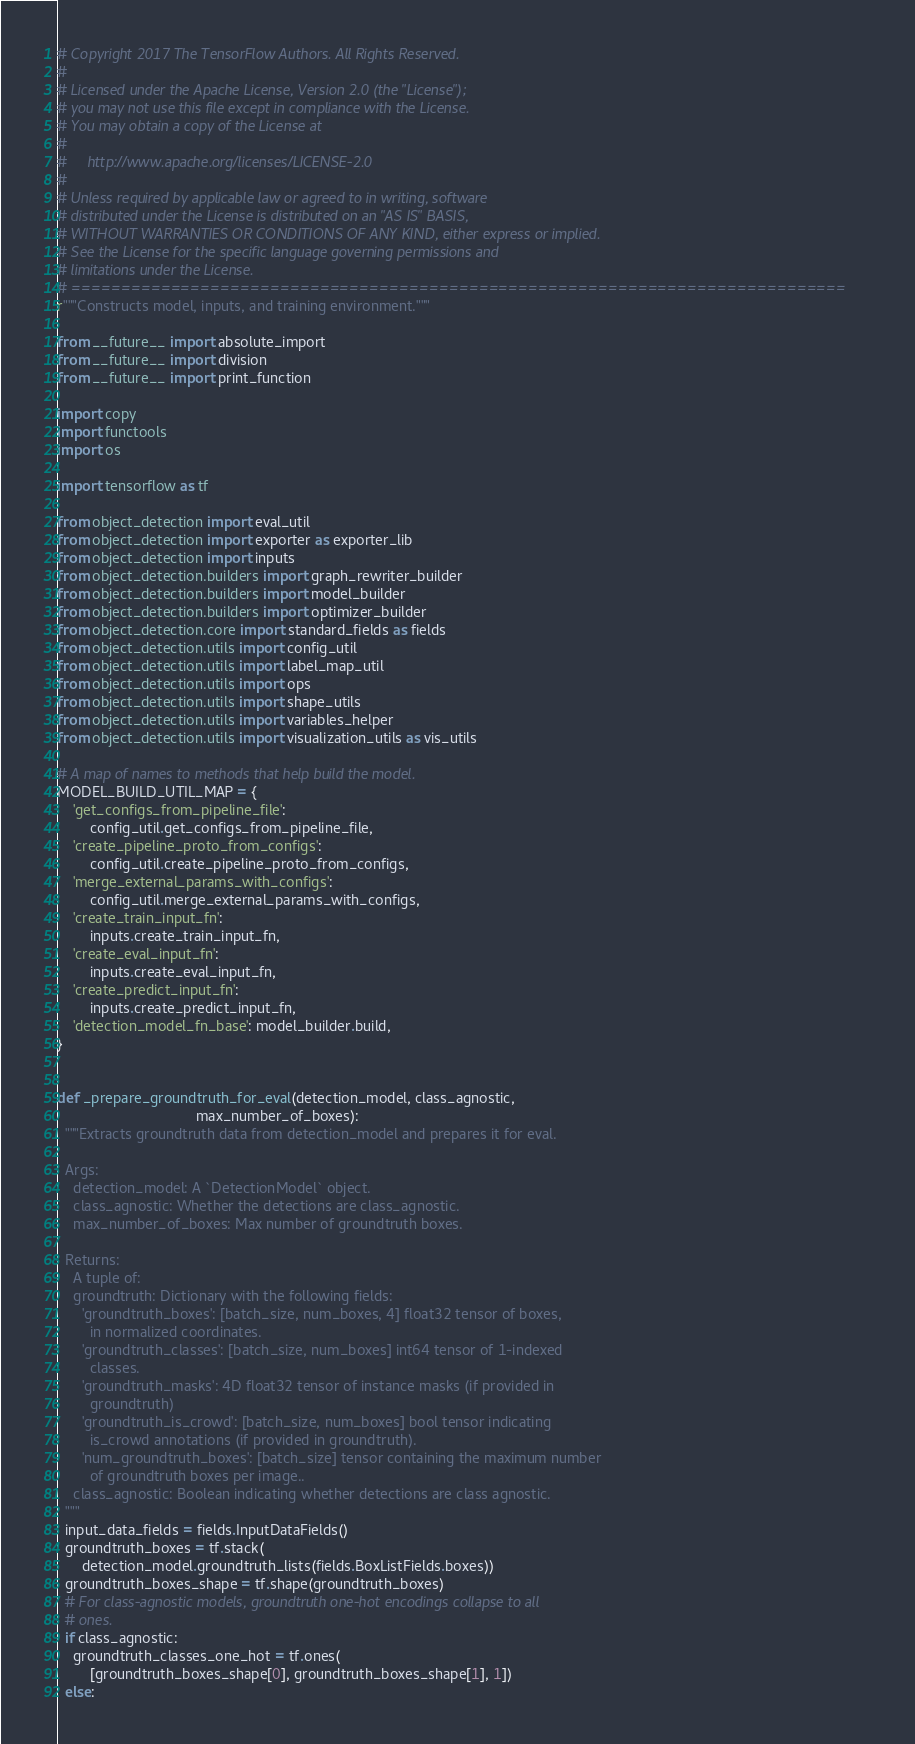Convert code to text. <code><loc_0><loc_0><loc_500><loc_500><_Python_># Copyright 2017 The TensorFlow Authors. All Rights Reserved.
#
# Licensed under the Apache License, Version 2.0 (the "License");
# you may not use this file except in compliance with the License.
# You may obtain a copy of the License at
#
#     http://www.apache.org/licenses/LICENSE-2.0
#
# Unless required by applicable law or agreed to in writing, software
# distributed under the License is distributed on an "AS IS" BASIS,
# WITHOUT WARRANTIES OR CONDITIONS OF ANY KIND, either express or implied.
# See the License for the specific language governing permissions and
# limitations under the License.
# ==============================================================================
r"""Constructs model, inputs, and training environment."""

from __future__ import absolute_import
from __future__ import division
from __future__ import print_function

import copy
import functools
import os

import tensorflow as tf

from object_detection import eval_util
from object_detection import exporter as exporter_lib
from object_detection import inputs
from object_detection.builders import graph_rewriter_builder
from object_detection.builders import model_builder
from object_detection.builders import optimizer_builder
from object_detection.core import standard_fields as fields
from object_detection.utils import config_util
from object_detection.utils import label_map_util
from object_detection.utils import ops
from object_detection.utils import shape_utils
from object_detection.utils import variables_helper
from object_detection.utils import visualization_utils as vis_utils

# A map of names to methods that help build the model.
MODEL_BUILD_UTIL_MAP = {
    'get_configs_from_pipeline_file':
        config_util.get_configs_from_pipeline_file,
    'create_pipeline_proto_from_configs':
        config_util.create_pipeline_proto_from_configs,
    'merge_external_params_with_configs':
        config_util.merge_external_params_with_configs,
    'create_train_input_fn':
        inputs.create_train_input_fn,
    'create_eval_input_fn':
        inputs.create_eval_input_fn,
    'create_predict_input_fn':
        inputs.create_predict_input_fn,
    'detection_model_fn_base': model_builder.build,
}


def _prepare_groundtruth_for_eval(detection_model, class_agnostic,
                                  max_number_of_boxes):
  """Extracts groundtruth data from detection_model and prepares it for eval.

  Args:
    detection_model: A `DetectionModel` object.
    class_agnostic: Whether the detections are class_agnostic.
    max_number_of_boxes: Max number of groundtruth boxes.

  Returns:
    A tuple of:
    groundtruth: Dictionary with the following fields:
      'groundtruth_boxes': [batch_size, num_boxes, 4] float32 tensor of boxes,
        in normalized coordinates.
      'groundtruth_classes': [batch_size, num_boxes] int64 tensor of 1-indexed
        classes.
      'groundtruth_masks': 4D float32 tensor of instance masks (if provided in
        groundtruth)
      'groundtruth_is_crowd': [batch_size, num_boxes] bool tensor indicating
        is_crowd annotations (if provided in groundtruth).
      'num_groundtruth_boxes': [batch_size] tensor containing the maximum number
        of groundtruth boxes per image..
    class_agnostic: Boolean indicating whether detections are class agnostic.
  """
  input_data_fields = fields.InputDataFields()
  groundtruth_boxes = tf.stack(
      detection_model.groundtruth_lists(fields.BoxListFields.boxes))
  groundtruth_boxes_shape = tf.shape(groundtruth_boxes)
  # For class-agnostic models, groundtruth one-hot encodings collapse to all
  # ones.
  if class_agnostic:
    groundtruth_classes_one_hot = tf.ones(
        [groundtruth_boxes_shape[0], groundtruth_boxes_shape[1], 1])
  else:</code> 